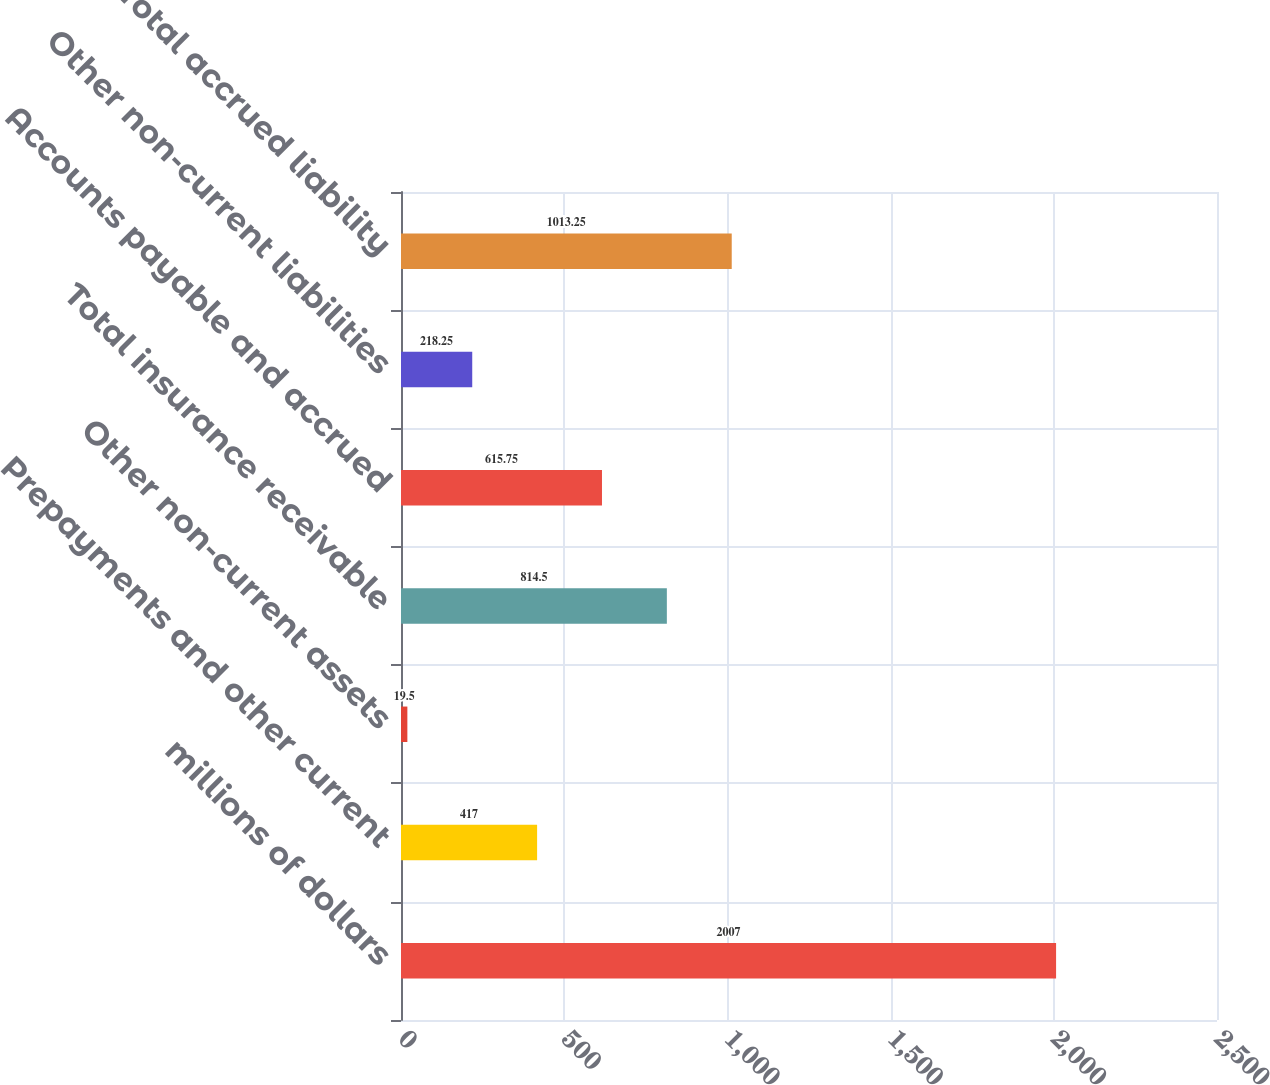<chart> <loc_0><loc_0><loc_500><loc_500><bar_chart><fcel>millions of dollars<fcel>Prepayments and other current<fcel>Other non-current assets<fcel>Total insurance receivable<fcel>Accounts payable and accrued<fcel>Other non-current liabilities<fcel>Total accrued liability<nl><fcel>2007<fcel>417<fcel>19.5<fcel>814.5<fcel>615.75<fcel>218.25<fcel>1013.25<nl></chart> 